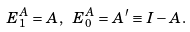Convert formula to latex. <formula><loc_0><loc_0><loc_500><loc_500>E ^ { A } _ { 1 } = A , \ E ^ { A } _ { 0 } = A ^ { \prime } \equiv I - A .</formula> 